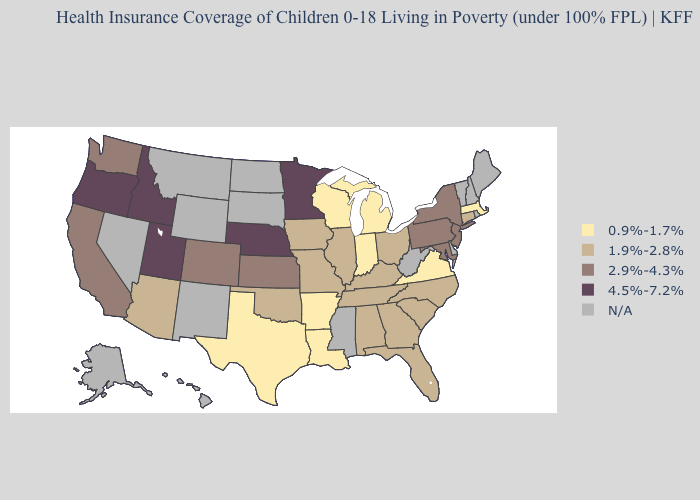What is the highest value in states that border Ohio?
Quick response, please. 2.9%-4.3%. What is the lowest value in states that border Michigan?
Answer briefly. 0.9%-1.7%. What is the value of Wyoming?
Keep it brief. N/A. Name the states that have a value in the range 4.5%-7.2%?
Be succinct. Idaho, Minnesota, Nebraska, Oregon, Utah. Is the legend a continuous bar?
Be succinct. No. What is the highest value in the USA?
Give a very brief answer. 4.5%-7.2%. Name the states that have a value in the range 0.9%-1.7%?
Write a very short answer. Arkansas, Indiana, Louisiana, Massachusetts, Michigan, Texas, Virginia, Wisconsin. Does the map have missing data?
Short answer required. Yes. Which states hav the highest value in the West?
Give a very brief answer. Idaho, Oregon, Utah. Among the states that border Maryland , which have the lowest value?
Short answer required. Virginia. Which states have the highest value in the USA?
Short answer required. Idaho, Minnesota, Nebraska, Oregon, Utah. What is the value of Florida?
Answer briefly. 1.9%-2.8%. What is the highest value in the USA?
Quick response, please. 4.5%-7.2%. 